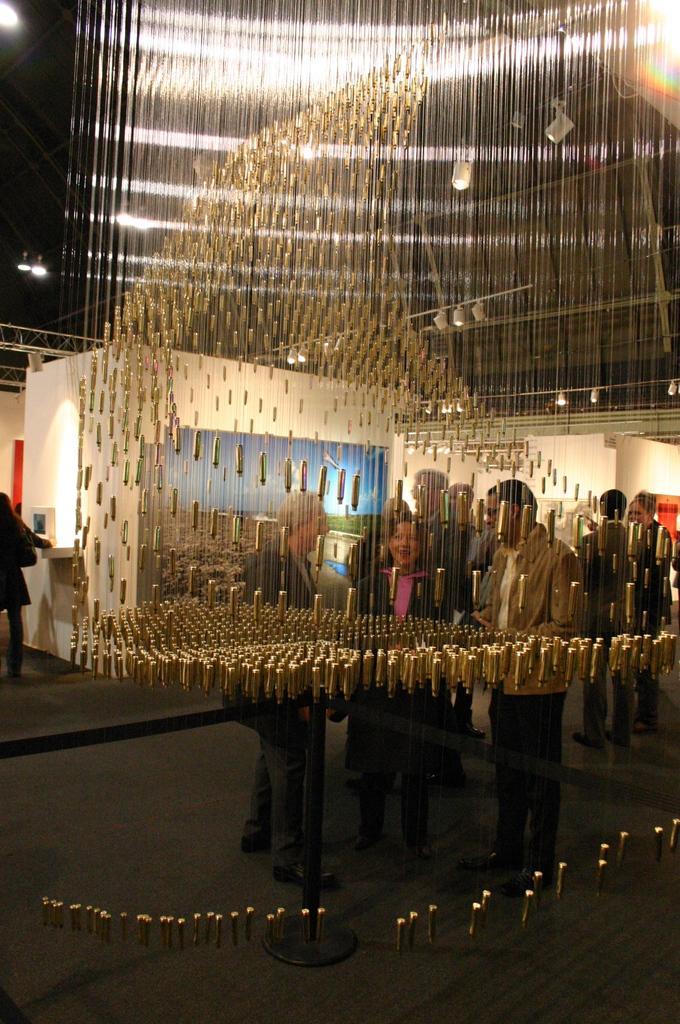Can you describe this image briefly? In this image I can see number of gold color decorative items, few lights, few persons standing on the floor, a black colored pole and in the background I can see the cream colored wall and a person standing. To the top of the image I can see the dark sky. 